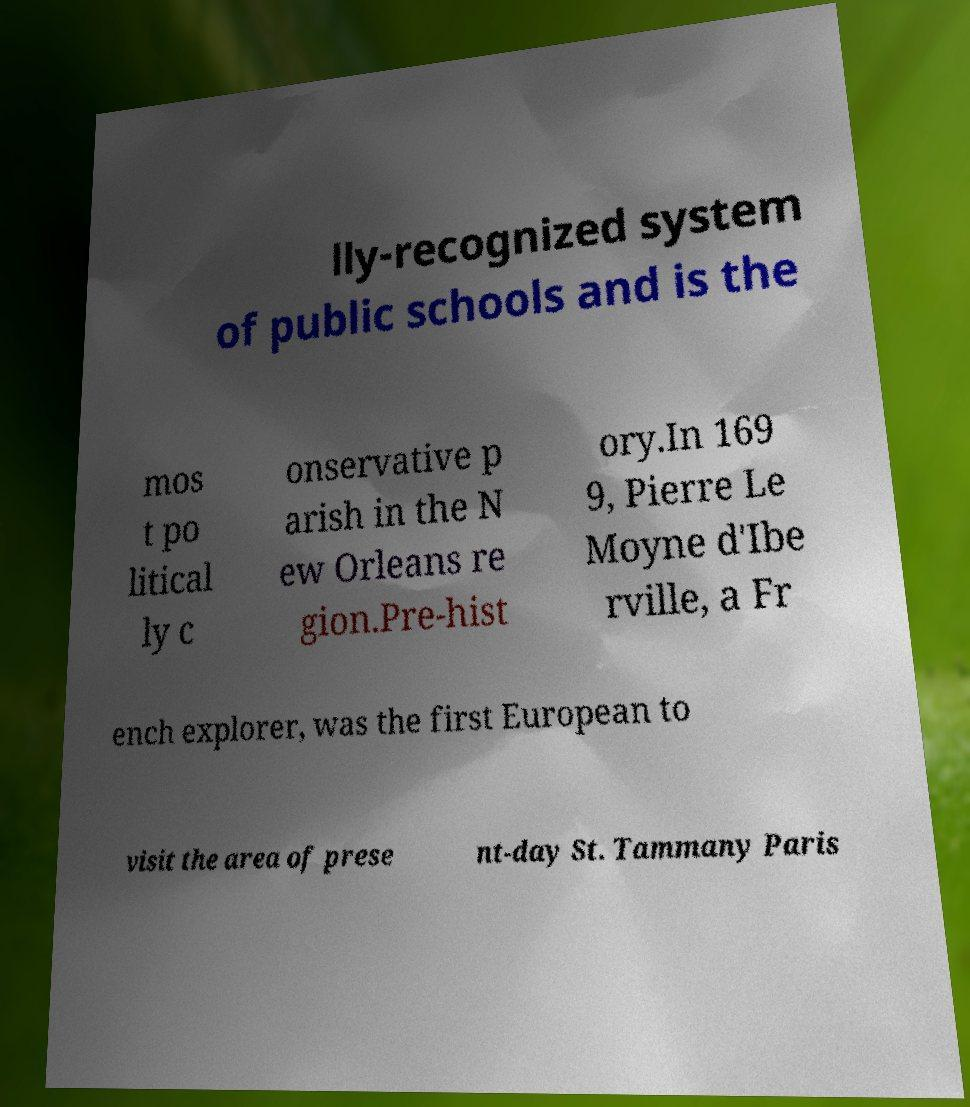Could you extract and type out the text from this image? lly-recognized system of public schools and is the mos t po litical ly c onservative p arish in the N ew Orleans re gion.Pre-hist ory.In 169 9, Pierre Le Moyne d'Ibe rville, a Fr ench explorer, was the first European to visit the area of prese nt-day St. Tammany Paris 